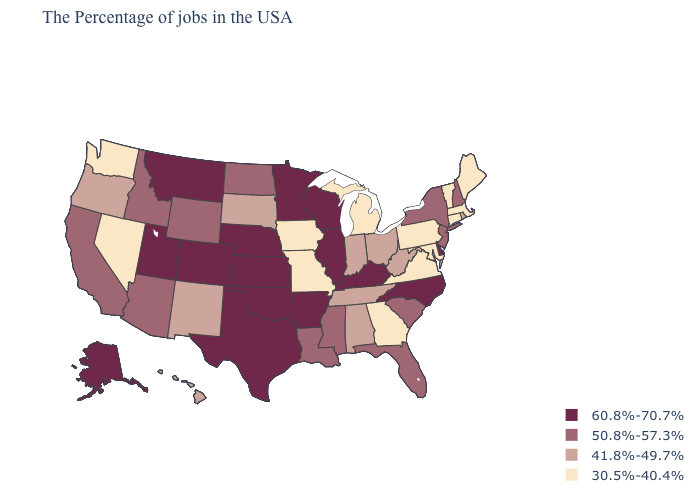What is the value of Oklahoma?
Concise answer only. 60.8%-70.7%. Name the states that have a value in the range 30.5%-40.4%?
Short answer required. Maine, Massachusetts, Vermont, Connecticut, Maryland, Pennsylvania, Virginia, Georgia, Michigan, Missouri, Iowa, Nevada, Washington. What is the value of Minnesota?
Write a very short answer. 60.8%-70.7%. Name the states that have a value in the range 50.8%-57.3%?
Write a very short answer. New Hampshire, New York, New Jersey, South Carolina, Florida, Mississippi, Louisiana, North Dakota, Wyoming, Arizona, Idaho, California. Which states have the lowest value in the USA?
Short answer required. Maine, Massachusetts, Vermont, Connecticut, Maryland, Pennsylvania, Virginia, Georgia, Michigan, Missouri, Iowa, Nevada, Washington. How many symbols are there in the legend?
Concise answer only. 4. Does Virginia have the highest value in the South?
Short answer required. No. Name the states that have a value in the range 60.8%-70.7%?
Give a very brief answer. Delaware, North Carolina, Kentucky, Wisconsin, Illinois, Arkansas, Minnesota, Kansas, Nebraska, Oklahoma, Texas, Colorado, Utah, Montana, Alaska. Does the first symbol in the legend represent the smallest category?
Answer briefly. No. Name the states that have a value in the range 30.5%-40.4%?
Concise answer only. Maine, Massachusetts, Vermont, Connecticut, Maryland, Pennsylvania, Virginia, Georgia, Michigan, Missouri, Iowa, Nevada, Washington. What is the value of Vermont?
Short answer required. 30.5%-40.4%. What is the lowest value in the West?
Keep it brief. 30.5%-40.4%. What is the value of Maine?
Short answer required. 30.5%-40.4%. What is the highest value in the USA?
Quick response, please. 60.8%-70.7%. Among the states that border Connecticut , which have the lowest value?
Be succinct. Massachusetts. 